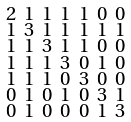<formula> <loc_0><loc_0><loc_500><loc_500>\begin{smallmatrix} 2 & 1 & 1 & 1 & 1 & 0 & 0 \\ 1 & 3 & 1 & 1 & 1 & 1 & 1 \\ 1 & 1 & 3 & 1 & 1 & 0 & 0 \\ 1 & 1 & 1 & 3 & 0 & 1 & 0 \\ 1 & 1 & 1 & 0 & 3 & 0 & 0 \\ 0 & 1 & 0 & 1 & 0 & 3 & 1 \\ 0 & 1 & 0 & 0 & 0 & 1 & 3 \end{smallmatrix}</formula> 